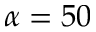Convert formula to latex. <formula><loc_0><loc_0><loc_500><loc_500>\alpha = 5 0</formula> 